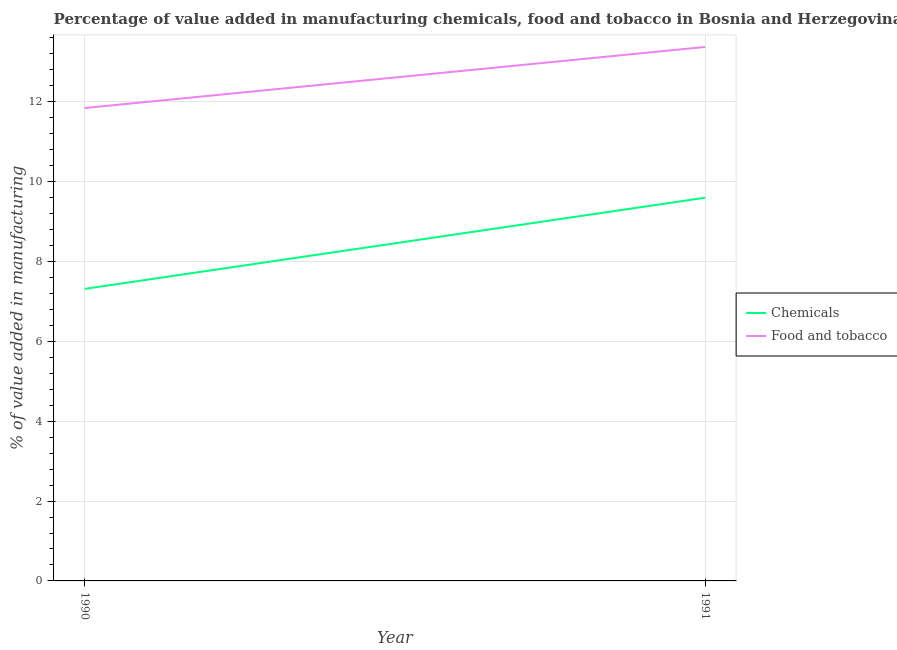How many different coloured lines are there?
Your response must be concise. 2. Does the line corresponding to value added by manufacturing food and tobacco intersect with the line corresponding to value added by  manufacturing chemicals?
Give a very brief answer. No. Is the number of lines equal to the number of legend labels?
Offer a terse response. Yes. What is the value added by manufacturing food and tobacco in 1991?
Provide a succinct answer. 13.37. Across all years, what is the maximum value added by  manufacturing chemicals?
Offer a very short reply. 9.6. Across all years, what is the minimum value added by manufacturing food and tobacco?
Provide a short and direct response. 11.85. What is the total value added by manufacturing food and tobacco in the graph?
Keep it short and to the point. 25.22. What is the difference between the value added by  manufacturing chemicals in 1990 and that in 1991?
Your response must be concise. -2.28. What is the difference between the value added by  manufacturing chemicals in 1990 and the value added by manufacturing food and tobacco in 1991?
Give a very brief answer. -6.06. What is the average value added by  manufacturing chemicals per year?
Your response must be concise. 8.46. In the year 1990, what is the difference between the value added by manufacturing food and tobacco and value added by  manufacturing chemicals?
Give a very brief answer. 4.53. What is the ratio of the value added by  manufacturing chemicals in 1990 to that in 1991?
Keep it short and to the point. 0.76. Is the value added by  manufacturing chemicals strictly greater than the value added by manufacturing food and tobacco over the years?
Offer a terse response. No. How many lines are there?
Ensure brevity in your answer.  2. How many years are there in the graph?
Give a very brief answer. 2. Are the values on the major ticks of Y-axis written in scientific E-notation?
Offer a very short reply. No. Does the graph contain grids?
Your response must be concise. Yes. Where does the legend appear in the graph?
Provide a short and direct response. Center right. How many legend labels are there?
Provide a succinct answer. 2. How are the legend labels stacked?
Give a very brief answer. Vertical. What is the title of the graph?
Make the answer very short. Percentage of value added in manufacturing chemicals, food and tobacco in Bosnia and Herzegovina. Does "By country of asylum" appear as one of the legend labels in the graph?
Your answer should be compact. No. What is the label or title of the Y-axis?
Your answer should be compact. % of value added in manufacturing. What is the % of value added in manufacturing in Chemicals in 1990?
Provide a succinct answer. 7.31. What is the % of value added in manufacturing of Food and tobacco in 1990?
Offer a terse response. 11.85. What is the % of value added in manufacturing in Chemicals in 1991?
Your response must be concise. 9.6. What is the % of value added in manufacturing in Food and tobacco in 1991?
Give a very brief answer. 13.37. Across all years, what is the maximum % of value added in manufacturing of Chemicals?
Keep it short and to the point. 9.6. Across all years, what is the maximum % of value added in manufacturing of Food and tobacco?
Provide a short and direct response. 13.37. Across all years, what is the minimum % of value added in manufacturing in Chemicals?
Ensure brevity in your answer.  7.31. Across all years, what is the minimum % of value added in manufacturing of Food and tobacco?
Your answer should be very brief. 11.85. What is the total % of value added in manufacturing of Chemicals in the graph?
Give a very brief answer. 16.91. What is the total % of value added in manufacturing of Food and tobacco in the graph?
Offer a terse response. 25.22. What is the difference between the % of value added in manufacturing of Chemicals in 1990 and that in 1991?
Offer a terse response. -2.28. What is the difference between the % of value added in manufacturing of Food and tobacco in 1990 and that in 1991?
Offer a terse response. -1.53. What is the difference between the % of value added in manufacturing in Chemicals in 1990 and the % of value added in manufacturing in Food and tobacco in 1991?
Offer a terse response. -6.06. What is the average % of value added in manufacturing of Chemicals per year?
Ensure brevity in your answer.  8.46. What is the average % of value added in manufacturing of Food and tobacco per year?
Offer a very short reply. 12.61. In the year 1990, what is the difference between the % of value added in manufacturing in Chemicals and % of value added in manufacturing in Food and tobacco?
Offer a terse response. -4.53. In the year 1991, what is the difference between the % of value added in manufacturing of Chemicals and % of value added in manufacturing of Food and tobacco?
Keep it short and to the point. -3.78. What is the ratio of the % of value added in manufacturing of Chemicals in 1990 to that in 1991?
Your answer should be very brief. 0.76. What is the ratio of the % of value added in manufacturing in Food and tobacco in 1990 to that in 1991?
Provide a succinct answer. 0.89. What is the difference between the highest and the second highest % of value added in manufacturing in Chemicals?
Provide a succinct answer. 2.28. What is the difference between the highest and the second highest % of value added in manufacturing in Food and tobacco?
Your response must be concise. 1.53. What is the difference between the highest and the lowest % of value added in manufacturing in Chemicals?
Your response must be concise. 2.28. What is the difference between the highest and the lowest % of value added in manufacturing of Food and tobacco?
Provide a short and direct response. 1.53. 